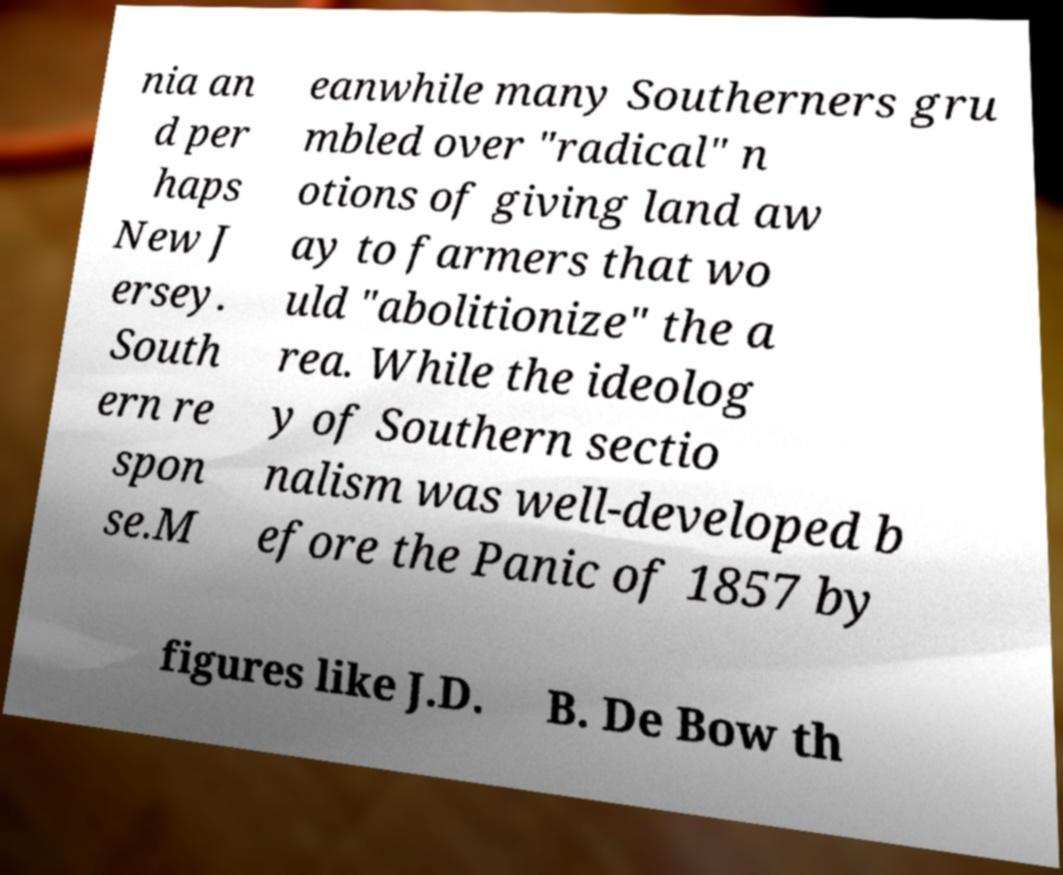Can you accurately transcribe the text from the provided image for me? nia an d per haps New J ersey. South ern re spon se.M eanwhile many Southerners gru mbled over "radical" n otions of giving land aw ay to farmers that wo uld "abolitionize" the a rea. While the ideolog y of Southern sectio nalism was well-developed b efore the Panic of 1857 by figures like J.D. B. De Bow th 